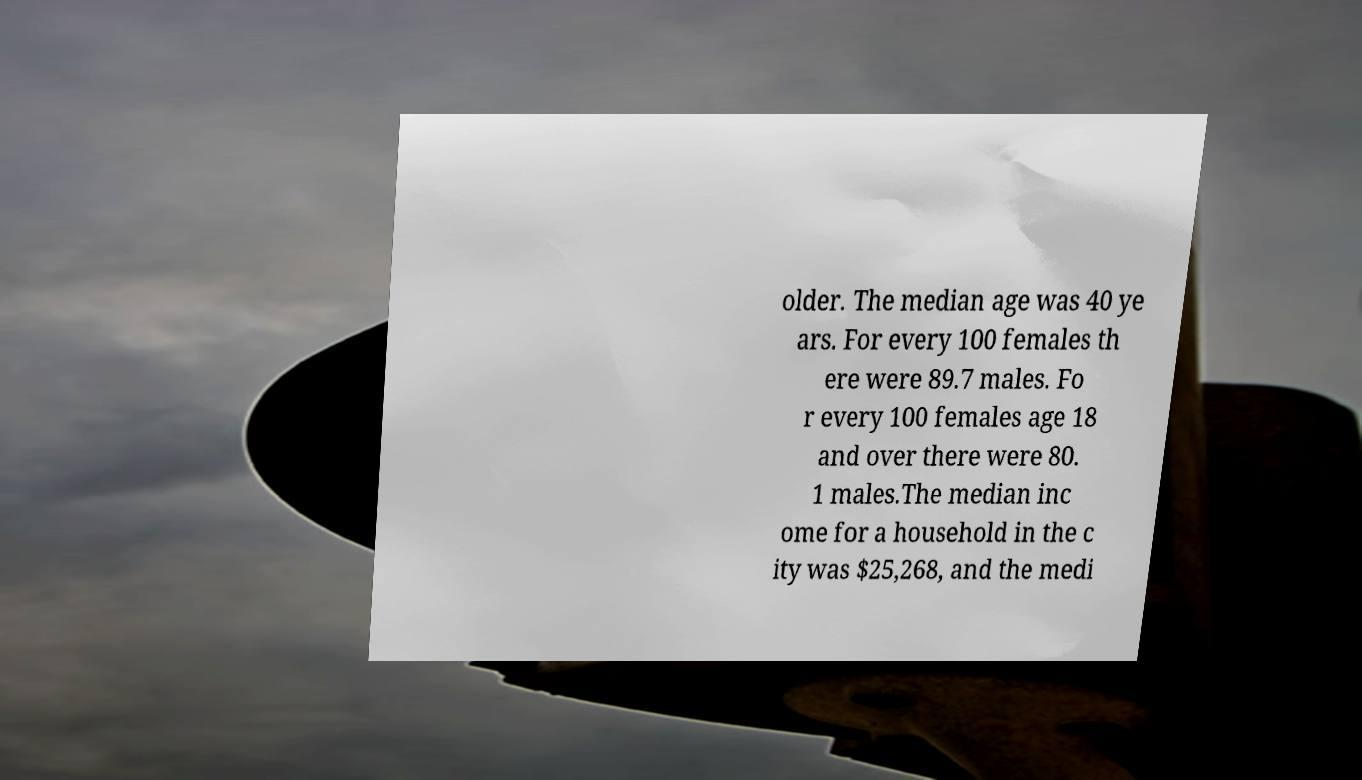For documentation purposes, I need the text within this image transcribed. Could you provide that? older. The median age was 40 ye ars. For every 100 females th ere were 89.7 males. Fo r every 100 females age 18 and over there were 80. 1 males.The median inc ome for a household in the c ity was $25,268, and the medi 